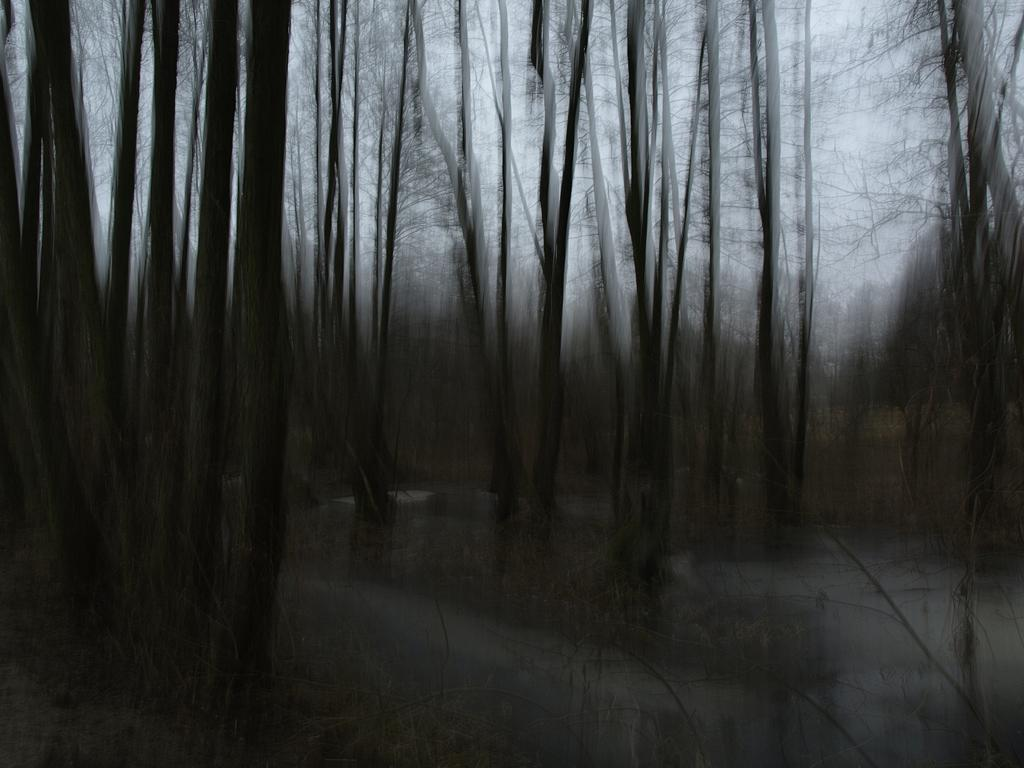What type of vegetation can be seen in the image? There are trees in the image. What can be seen in the background of the image? The background of the image includes trees and the sky. What is present at the bottom of the image? Grass and water are present at the bottom of the image. How would you describe the overall clarity of the image? The image is blurred. Can you see any underwear hanging on the trees in the image? There is no underwear present in the image; it only features trees, grass, water, and the sky. 